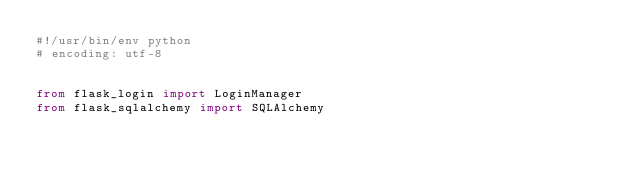Convert code to text. <code><loc_0><loc_0><loc_500><loc_500><_Python_>#!/usr/bin/env python
# encoding: utf-8


from flask_login import LoginManager
from flask_sqlalchemy import SQLAlchemy</code> 